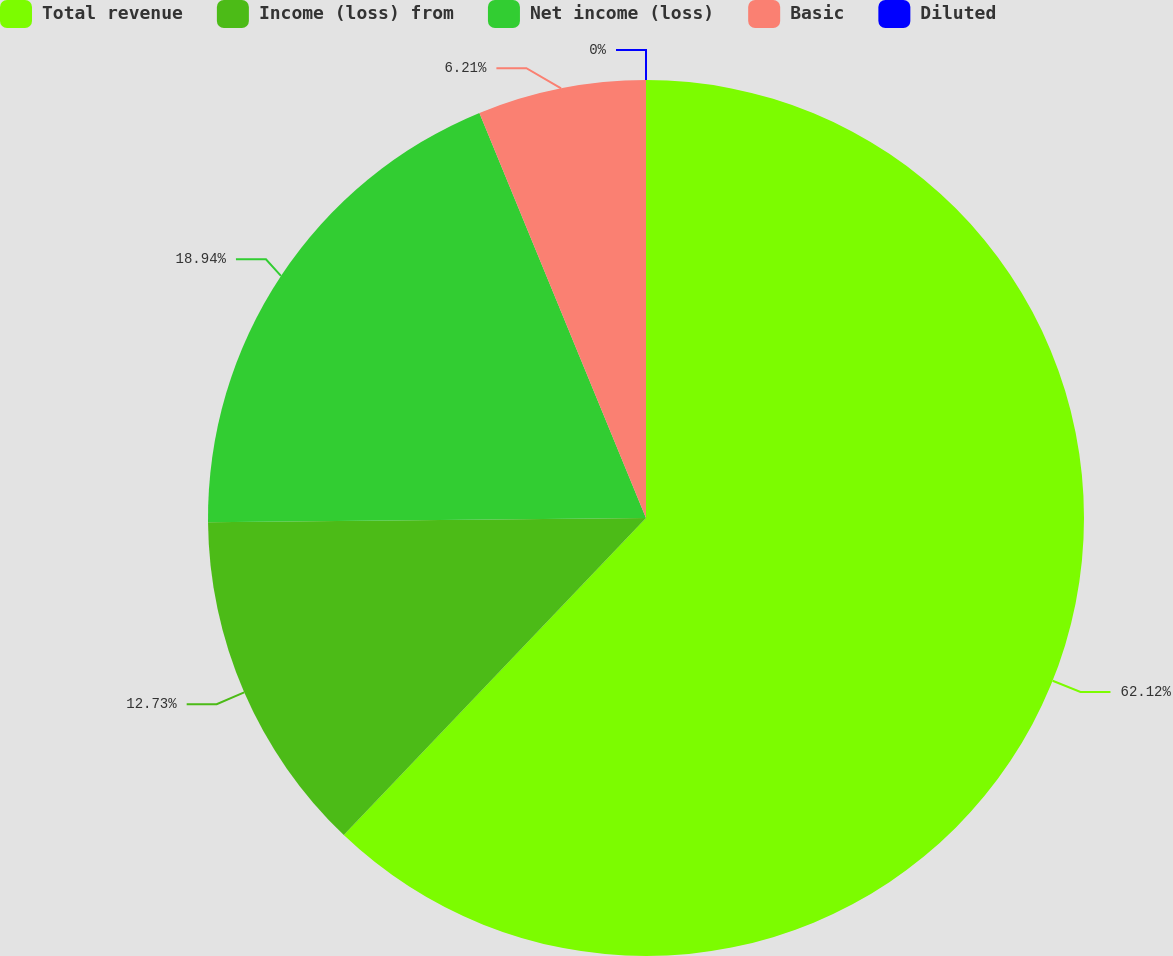<chart> <loc_0><loc_0><loc_500><loc_500><pie_chart><fcel>Total revenue<fcel>Income (loss) from<fcel>Net income (loss)<fcel>Basic<fcel>Diluted<nl><fcel>62.12%<fcel>12.73%<fcel>18.94%<fcel>6.21%<fcel>0.0%<nl></chart> 